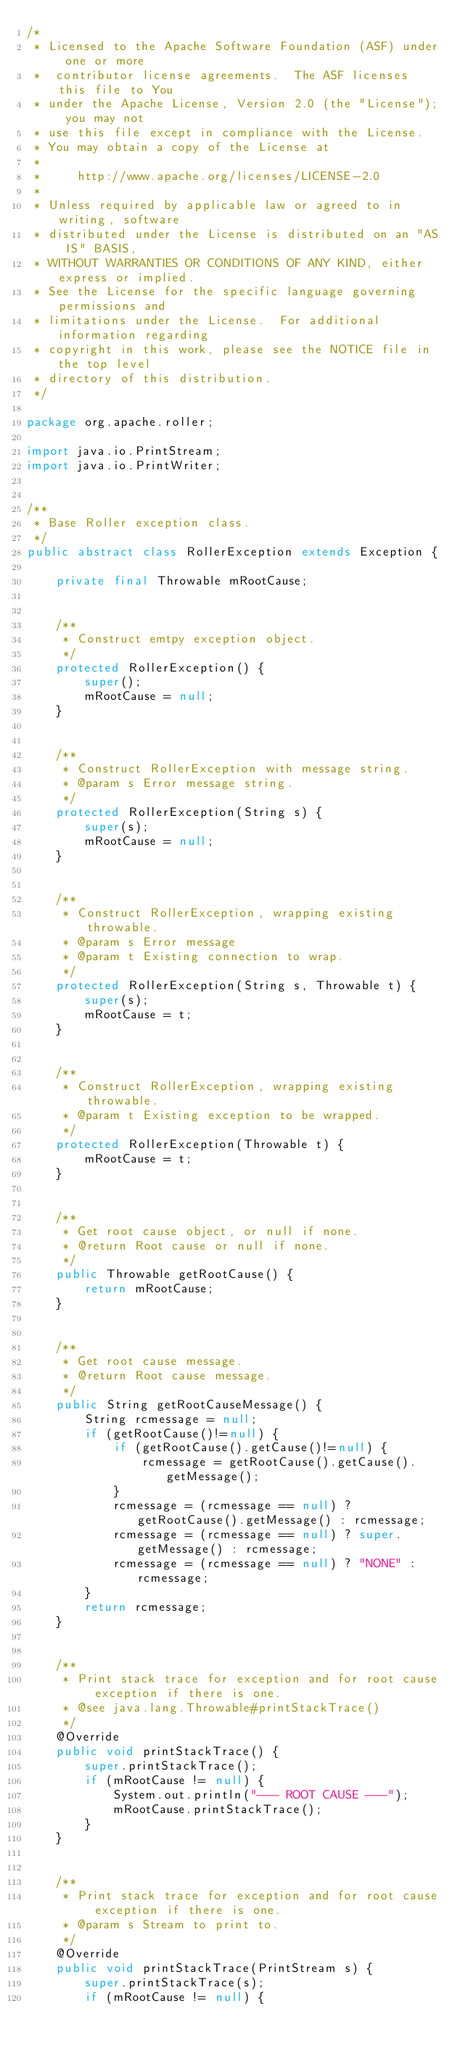<code> <loc_0><loc_0><loc_500><loc_500><_Java_>/*
 * Licensed to the Apache Software Foundation (ASF) under one or more
 *  contributor license agreements.  The ASF licenses this file to You
 * under the Apache License, Version 2.0 (the "License"); you may not
 * use this file except in compliance with the License.
 * You may obtain a copy of the License at
 *
 *     http://www.apache.org/licenses/LICENSE-2.0
 *
 * Unless required by applicable law or agreed to in writing, software
 * distributed under the License is distributed on an "AS IS" BASIS,
 * WITHOUT WARRANTIES OR CONDITIONS OF ANY KIND, either express or implied.
 * See the License for the specific language governing permissions and
 * limitations under the License.  For additional information regarding
 * copyright in this work, please see the NOTICE file in the top level
 * directory of this distribution.
 */

package org.apache.roller;

import java.io.PrintStream;
import java.io.PrintWriter;


/**
 * Base Roller exception class.
 */
public abstract class RollerException extends Exception {

    private final Throwable mRootCause;


    /**
     * Construct emtpy exception object.
     */
    protected RollerException() {
        super();
        mRootCause = null;
    }


    /**
     * Construct RollerException with message string.
     * @param s Error message string.
     */
    protected RollerException(String s) {
        super(s);
        mRootCause = null;
    }


    /**
     * Construct RollerException, wrapping existing throwable.
     * @param s Error message
     * @param t Existing connection to wrap.
     */
    protected RollerException(String s, Throwable t) {
        super(s);
        mRootCause = t;
    }


    /**
     * Construct RollerException, wrapping existing throwable.
     * @param t Existing exception to be wrapped.
     */
    protected RollerException(Throwable t) {
        mRootCause = t;
    }


    /**
     * Get root cause object, or null if none.
     * @return Root cause or null if none.
     */
    public Throwable getRootCause() {
        return mRootCause;
    }


    /**
     * Get root cause message.
     * @return Root cause message.
     */
    public String getRootCauseMessage() {
        String rcmessage = null;
        if (getRootCause()!=null) {
            if (getRootCause().getCause()!=null) {
                rcmessage = getRootCause().getCause().getMessage();
            }
            rcmessage = (rcmessage == null) ? getRootCause().getMessage() : rcmessage;
            rcmessage = (rcmessage == null) ? super.getMessage() : rcmessage;
            rcmessage = (rcmessage == null) ? "NONE" : rcmessage;
        }
        return rcmessage;
    }


    /**
     * Print stack trace for exception and for root cause exception if there is one.
     * @see java.lang.Throwable#printStackTrace()
     */
    @Override
    public void printStackTrace() {
        super.printStackTrace();
        if (mRootCause != null) {
            System.out.println("--- ROOT CAUSE ---");
            mRootCause.printStackTrace();
        }
    }


    /**
     * Print stack trace for exception and for root cause exception if there is one.
     * @param s Stream to print to.
     */
    @Override
    public void printStackTrace(PrintStream s) {
        super.printStackTrace(s);
        if (mRootCause != null) {</code> 